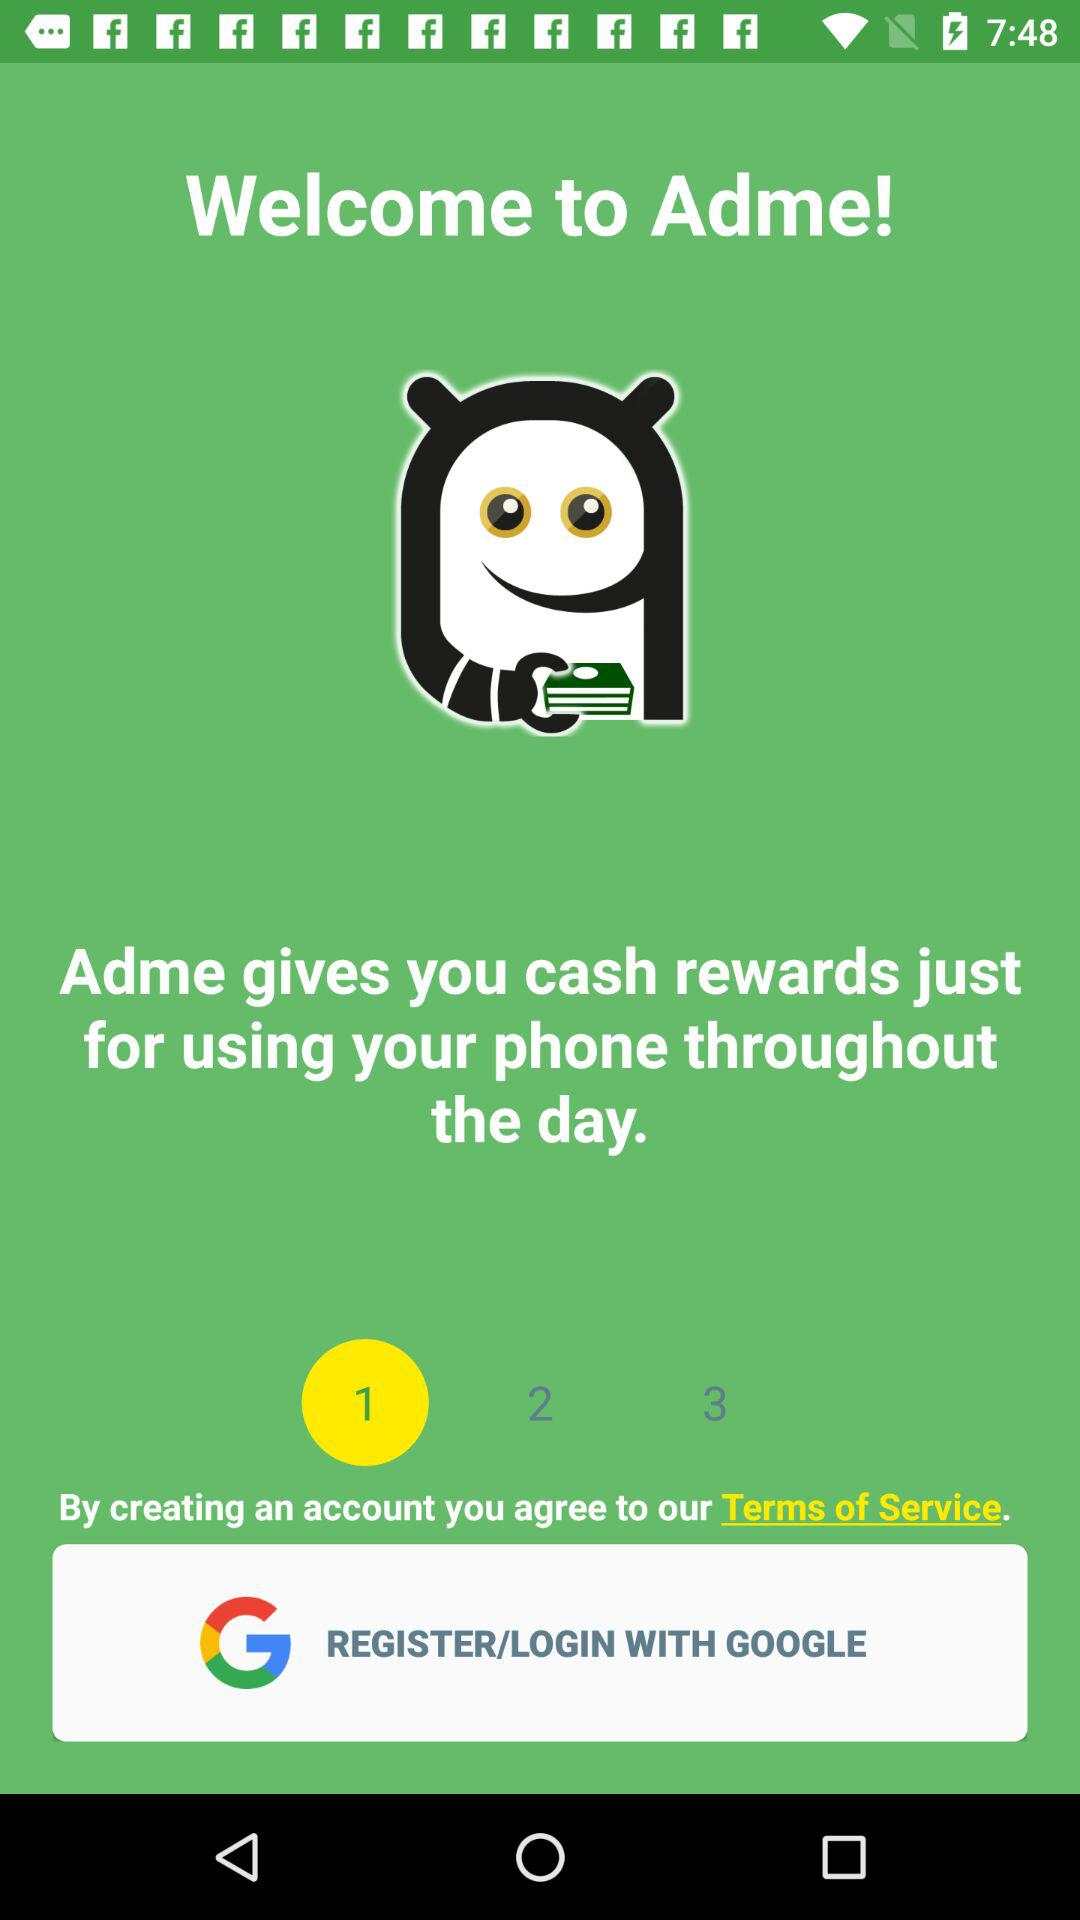What is the name of the application? The name of the application is "Adme". 